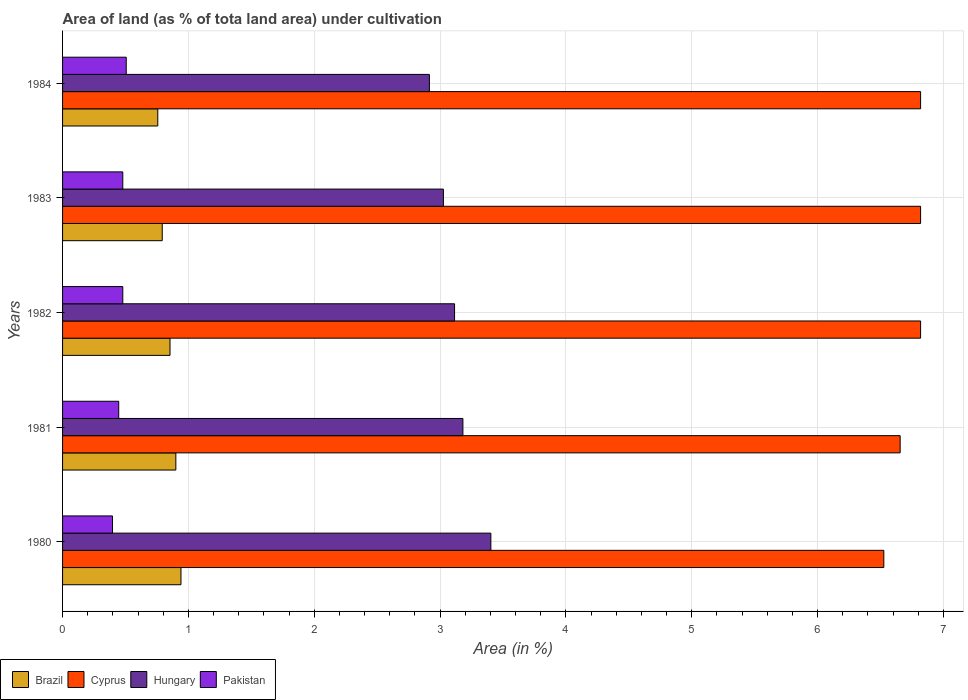How many groups of bars are there?
Give a very brief answer. 5. Are the number of bars per tick equal to the number of legend labels?
Provide a succinct answer. Yes. Are the number of bars on each tick of the Y-axis equal?
Your response must be concise. Yes. How many bars are there on the 2nd tick from the top?
Your answer should be compact. 4. What is the label of the 5th group of bars from the top?
Make the answer very short. 1980. What is the percentage of land under cultivation in Brazil in 1984?
Offer a very short reply. 0.76. Across all years, what is the maximum percentage of land under cultivation in Brazil?
Ensure brevity in your answer.  0.94. Across all years, what is the minimum percentage of land under cultivation in Hungary?
Ensure brevity in your answer.  2.91. In which year was the percentage of land under cultivation in Brazil maximum?
Make the answer very short. 1980. What is the total percentage of land under cultivation in Pakistan in the graph?
Give a very brief answer. 2.31. What is the difference between the percentage of land under cultivation in Hungary in 1980 and that in 1982?
Offer a terse response. 0.29. What is the difference between the percentage of land under cultivation in Brazil in 1983 and the percentage of land under cultivation in Cyprus in 1984?
Your answer should be very brief. -6.03. What is the average percentage of land under cultivation in Hungary per year?
Keep it short and to the point. 3.13. In the year 1984, what is the difference between the percentage of land under cultivation in Hungary and percentage of land under cultivation in Pakistan?
Give a very brief answer. 2.41. In how many years, is the percentage of land under cultivation in Pakistan greater than 1.2 %?
Your answer should be compact. 0. What is the ratio of the percentage of land under cultivation in Pakistan in 1981 to that in 1984?
Provide a short and direct response. 0.88. Is the difference between the percentage of land under cultivation in Hungary in 1982 and 1984 greater than the difference between the percentage of land under cultivation in Pakistan in 1982 and 1984?
Your answer should be very brief. Yes. What is the difference between the highest and the second highest percentage of land under cultivation in Hungary?
Offer a very short reply. 0.22. What is the difference between the highest and the lowest percentage of land under cultivation in Cyprus?
Give a very brief answer. 0.29. In how many years, is the percentage of land under cultivation in Pakistan greater than the average percentage of land under cultivation in Pakistan taken over all years?
Provide a succinct answer. 3. Is the sum of the percentage of land under cultivation in Brazil in 1982 and 1984 greater than the maximum percentage of land under cultivation in Pakistan across all years?
Your answer should be very brief. Yes. What does the 2nd bar from the top in 1980 represents?
Your answer should be very brief. Hungary. What is the difference between two consecutive major ticks on the X-axis?
Keep it short and to the point. 1. Are the values on the major ticks of X-axis written in scientific E-notation?
Ensure brevity in your answer.  No. Does the graph contain grids?
Offer a terse response. Yes. How are the legend labels stacked?
Keep it short and to the point. Horizontal. What is the title of the graph?
Your answer should be very brief. Area of land (as % of tota land area) under cultivation. Does "Morocco" appear as one of the legend labels in the graph?
Your answer should be compact. No. What is the label or title of the X-axis?
Give a very brief answer. Area (in %). What is the Area (in %) in Brazil in 1980?
Offer a terse response. 0.94. What is the Area (in %) of Cyprus in 1980?
Ensure brevity in your answer.  6.53. What is the Area (in %) of Hungary in 1980?
Give a very brief answer. 3.4. What is the Area (in %) of Pakistan in 1980?
Give a very brief answer. 0.4. What is the Area (in %) of Brazil in 1981?
Your answer should be very brief. 0.9. What is the Area (in %) in Cyprus in 1981?
Provide a short and direct response. 6.66. What is the Area (in %) of Hungary in 1981?
Your response must be concise. 3.18. What is the Area (in %) of Pakistan in 1981?
Give a very brief answer. 0.45. What is the Area (in %) of Brazil in 1982?
Provide a short and direct response. 0.85. What is the Area (in %) in Cyprus in 1982?
Your answer should be very brief. 6.82. What is the Area (in %) in Hungary in 1982?
Give a very brief answer. 3.11. What is the Area (in %) in Pakistan in 1982?
Give a very brief answer. 0.48. What is the Area (in %) in Brazil in 1983?
Provide a succinct answer. 0.79. What is the Area (in %) of Cyprus in 1983?
Provide a succinct answer. 6.82. What is the Area (in %) of Hungary in 1983?
Make the answer very short. 3.03. What is the Area (in %) of Pakistan in 1983?
Offer a very short reply. 0.48. What is the Area (in %) in Brazil in 1984?
Your answer should be very brief. 0.76. What is the Area (in %) of Cyprus in 1984?
Provide a succinct answer. 6.82. What is the Area (in %) of Hungary in 1984?
Provide a succinct answer. 2.91. What is the Area (in %) of Pakistan in 1984?
Provide a succinct answer. 0.51. Across all years, what is the maximum Area (in %) in Brazil?
Keep it short and to the point. 0.94. Across all years, what is the maximum Area (in %) in Cyprus?
Provide a short and direct response. 6.82. Across all years, what is the maximum Area (in %) of Hungary?
Offer a very short reply. 3.4. Across all years, what is the maximum Area (in %) in Pakistan?
Make the answer very short. 0.51. Across all years, what is the minimum Area (in %) of Brazil?
Ensure brevity in your answer.  0.76. Across all years, what is the minimum Area (in %) in Cyprus?
Keep it short and to the point. 6.53. Across all years, what is the minimum Area (in %) in Hungary?
Give a very brief answer. 2.91. Across all years, what is the minimum Area (in %) of Pakistan?
Provide a short and direct response. 0.4. What is the total Area (in %) of Brazil in the graph?
Ensure brevity in your answer.  4.24. What is the total Area (in %) of Cyprus in the graph?
Ensure brevity in your answer.  33.64. What is the total Area (in %) of Hungary in the graph?
Offer a very short reply. 15.64. What is the total Area (in %) of Pakistan in the graph?
Your answer should be very brief. 2.31. What is the difference between the Area (in %) in Brazil in 1980 and that in 1981?
Your response must be concise. 0.04. What is the difference between the Area (in %) in Cyprus in 1980 and that in 1981?
Your response must be concise. -0.13. What is the difference between the Area (in %) of Hungary in 1980 and that in 1981?
Provide a short and direct response. 0.22. What is the difference between the Area (in %) of Pakistan in 1980 and that in 1981?
Offer a very short reply. -0.05. What is the difference between the Area (in %) of Brazil in 1980 and that in 1982?
Ensure brevity in your answer.  0.09. What is the difference between the Area (in %) in Cyprus in 1980 and that in 1982?
Ensure brevity in your answer.  -0.29. What is the difference between the Area (in %) in Hungary in 1980 and that in 1982?
Provide a succinct answer. 0.29. What is the difference between the Area (in %) of Pakistan in 1980 and that in 1982?
Offer a very short reply. -0.08. What is the difference between the Area (in %) of Brazil in 1980 and that in 1983?
Give a very brief answer. 0.15. What is the difference between the Area (in %) of Cyprus in 1980 and that in 1983?
Provide a short and direct response. -0.29. What is the difference between the Area (in %) of Hungary in 1980 and that in 1983?
Your answer should be compact. 0.38. What is the difference between the Area (in %) of Pakistan in 1980 and that in 1983?
Ensure brevity in your answer.  -0.08. What is the difference between the Area (in %) of Brazil in 1980 and that in 1984?
Your answer should be very brief. 0.18. What is the difference between the Area (in %) of Cyprus in 1980 and that in 1984?
Provide a short and direct response. -0.29. What is the difference between the Area (in %) in Hungary in 1980 and that in 1984?
Your response must be concise. 0.49. What is the difference between the Area (in %) in Pakistan in 1980 and that in 1984?
Your answer should be very brief. -0.11. What is the difference between the Area (in %) in Brazil in 1981 and that in 1982?
Provide a succinct answer. 0.05. What is the difference between the Area (in %) of Cyprus in 1981 and that in 1982?
Offer a very short reply. -0.16. What is the difference between the Area (in %) in Hungary in 1981 and that in 1982?
Keep it short and to the point. 0.07. What is the difference between the Area (in %) in Pakistan in 1981 and that in 1982?
Make the answer very short. -0.03. What is the difference between the Area (in %) of Brazil in 1981 and that in 1983?
Offer a terse response. 0.11. What is the difference between the Area (in %) in Cyprus in 1981 and that in 1983?
Your response must be concise. -0.16. What is the difference between the Area (in %) of Hungary in 1981 and that in 1983?
Provide a short and direct response. 0.16. What is the difference between the Area (in %) of Pakistan in 1981 and that in 1983?
Provide a short and direct response. -0.03. What is the difference between the Area (in %) of Brazil in 1981 and that in 1984?
Offer a terse response. 0.14. What is the difference between the Area (in %) in Cyprus in 1981 and that in 1984?
Provide a succinct answer. -0.16. What is the difference between the Area (in %) in Hungary in 1981 and that in 1984?
Provide a short and direct response. 0.27. What is the difference between the Area (in %) of Pakistan in 1981 and that in 1984?
Ensure brevity in your answer.  -0.06. What is the difference between the Area (in %) of Brazil in 1982 and that in 1983?
Keep it short and to the point. 0.06. What is the difference between the Area (in %) in Hungary in 1982 and that in 1983?
Ensure brevity in your answer.  0.09. What is the difference between the Area (in %) of Pakistan in 1982 and that in 1983?
Offer a very short reply. 0. What is the difference between the Area (in %) of Brazil in 1982 and that in 1984?
Make the answer very short. 0.1. What is the difference between the Area (in %) in Hungary in 1982 and that in 1984?
Offer a very short reply. 0.2. What is the difference between the Area (in %) in Pakistan in 1982 and that in 1984?
Your answer should be compact. -0.03. What is the difference between the Area (in %) of Brazil in 1983 and that in 1984?
Make the answer very short. 0.04. What is the difference between the Area (in %) of Hungary in 1983 and that in 1984?
Your response must be concise. 0.11. What is the difference between the Area (in %) of Pakistan in 1983 and that in 1984?
Provide a succinct answer. -0.03. What is the difference between the Area (in %) of Brazil in 1980 and the Area (in %) of Cyprus in 1981?
Your response must be concise. -5.71. What is the difference between the Area (in %) of Brazil in 1980 and the Area (in %) of Hungary in 1981?
Your answer should be very brief. -2.24. What is the difference between the Area (in %) of Brazil in 1980 and the Area (in %) of Pakistan in 1981?
Provide a short and direct response. 0.49. What is the difference between the Area (in %) of Cyprus in 1980 and the Area (in %) of Hungary in 1981?
Offer a very short reply. 3.34. What is the difference between the Area (in %) of Cyprus in 1980 and the Area (in %) of Pakistan in 1981?
Provide a short and direct response. 6.08. What is the difference between the Area (in %) of Hungary in 1980 and the Area (in %) of Pakistan in 1981?
Your answer should be compact. 2.96. What is the difference between the Area (in %) in Brazil in 1980 and the Area (in %) in Cyprus in 1982?
Your answer should be compact. -5.88. What is the difference between the Area (in %) of Brazil in 1980 and the Area (in %) of Hungary in 1982?
Provide a short and direct response. -2.17. What is the difference between the Area (in %) in Brazil in 1980 and the Area (in %) in Pakistan in 1982?
Your answer should be very brief. 0.46. What is the difference between the Area (in %) in Cyprus in 1980 and the Area (in %) in Hungary in 1982?
Provide a succinct answer. 3.41. What is the difference between the Area (in %) of Cyprus in 1980 and the Area (in %) of Pakistan in 1982?
Your response must be concise. 6.05. What is the difference between the Area (in %) of Hungary in 1980 and the Area (in %) of Pakistan in 1982?
Give a very brief answer. 2.92. What is the difference between the Area (in %) of Brazil in 1980 and the Area (in %) of Cyprus in 1983?
Provide a succinct answer. -5.88. What is the difference between the Area (in %) of Brazil in 1980 and the Area (in %) of Hungary in 1983?
Your answer should be compact. -2.09. What is the difference between the Area (in %) of Brazil in 1980 and the Area (in %) of Pakistan in 1983?
Provide a succinct answer. 0.46. What is the difference between the Area (in %) of Cyprus in 1980 and the Area (in %) of Hungary in 1983?
Give a very brief answer. 3.5. What is the difference between the Area (in %) in Cyprus in 1980 and the Area (in %) in Pakistan in 1983?
Your answer should be very brief. 6.05. What is the difference between the Area (in %) of Hungary in 1980 and the Area (in %) of Pakistan in 1983?
Your response must be concise. 2.92. What is the difference between the Area (in %) in Brazil in 1980 and the Area (in %) in Cyprus in 1984?
Keep it short and to the point. -5.88. What is the difference between the Area (in %) of Brazil in 1980 and the Area (in %) of Hungary in 1984?
Your answer should be compact. -1.97. What is the difference between the Area (in %) in Brazil in 1980 and the Area (in %) in Pakistan in 1984?
Ensure brevity in your answer.  0.43. What is the difference between the Area (in %) in Cyprus in 1980 and the Area (in %) in Hungary in 1984?
Keep it short and to the point. 3.61. What is the difference between the Area (in %) of Cyprus in 1980 and the Area (in %) of Pakistan in 1984?
Provide a succinct answer. 6.02. What is the difference between the Area (in %) in Hungary in 1980 and the Area (in %) in Pakistan in 1984?
Provide a short and direct response. 2.9. What is the difference between the Area (in %) of Brazil in 1981 and the Area (in %) of Cyprus in 1982?
Make the answer very short. -5.92. What is the difference between the Area (in %) in Brazil in 1981 and the Area (in %) in Hungary in 1982?
Keep it short and to the point. -2.21. What is the difference between the Area (in %) of Brazil in 1981 and the Area (in %) of Pakistan in 1982?
Ensure brevity in your answer.  0.42. What is the difference between the Area (in %) of Cyprus in 1981 and the Area (in %) of Hungary in 1982?
Give a very brief answer. 3.54. What is the difference between the Area (in %) in Cyprus in 1981 and the Area (in %) in Pakistan in 1982?
Give a very brief answer. 6.18. What is the difference between the Area (in %) of Hungary in 1981 and the Area (in %) of Pakistan in 1982?
Keep it short and to the point. 2.7. What is the difference between the Area (in %) of Brazil in 1981 and the Area (in %) of Cyprus in 1983?
Provide a short and direct response. -5.92. What is the difference between the Area (in %) of Brazil in 1981 and the Area (in %) of Hungary in 1983?
Offer a terse response. -2.13. What is the difference between the Area (in %) of Brazil in 1981 and the Area (in %) of Pakistan in 1983?
Make the answer very short. 0.42. What is the difference between the Area (in %) in Cyprus in 1981 and the Area (in %) in Hungary in 1983?
Your answer should be very brief. 3.63. What is the difference between the Area (in %) of Cyprus in 1981 and the Area (in %) of Pakistan in 1983?
Your answer should be very brief. 6.18. What is the difference between the Area (in %) in Hungary in 1981 and the Area (in %) in Pakistan in 1983?
Keep it short and to the point. 2.7. What is the difference between the Area (in %) in Brazil in 1981 and the Area (in %) in Cyprus in 1984?
Your response must be concise. -5.92. What is the difference between the Area (in %) of Brazil in 1981 and the Area (in %) of Hungary in 1984?
Give a very brief answer. -2.01. What is the difference between the Area (in %) of Brazil in 1981 and the Area (in %) of Pakistan in 1984?
Your answer should be very brief. 0.39. What is the difference between the Area (in %) of Cyprus in 1981 and the Area (in %) of Hungary in 1984?
Offer a terse response. 3.74. What is the difference between the Area (in %) of Cyprus in 1981 and the Area (in %) of Pakistan in 1984?
Provide a short and direct response. 6.15. What is the difference between the Area (in %) of Hungary in 1981 and the Area (in %) of Pakistan in 1984?
Give a very brief answer. 2.68. What is the difference between the Area (in %) in Brazil in 1982 and the Area (in %) in Cyprus in 1983?
Keep it short and to the point. -5.96. What is the difference between the Area (in %) of Brazil in 1982 and the Area (in %) of Hungary in 1983?
Give a very brief answer. -2.17. What is the difference between the Area (in %) in Brazil in 1982 and the Area (in %) in Pakistan in 1983?
Offer a very short reply. 0.38. What is the difference between the Area (in %) in Cyprus in 1982 and the Area (in %) in Hungary in 1983?
Your answer should be compact. 3.79. What is the difference between the Area (in %) of Cyprus in 1982 and the Area (in %) of Pakistan in 1983?
Provide a succinct answer. 6.34. What is the difference between the Area (in %) of Hungary in 1982 and the Area (in %) of Pakistan in 1983?
Your answer should be compact. 2.64. What is the difference between the Area (in %) in Brazil in 1982 and the Area (in %) in Cyprus in 1984?
Offer a very short reply. -5.96. What is the difference between the Area (in %) in Brazil in 1982 and the Area (in %) in Hungary in 1984?
Offer a terse response. -2.06. What is the difference between the Area (in %) of Brazil in 1982 and the Area (in %) of Pakistan in 1984?
Your response must be concise. 0.35. What is the difference between the Area (in %) in Cyprus in 1982 and the Area (in %) in Hungary in 1984?
Offer a very short reply. 3.9. What is the difference between the Area (in %) of Cyprus in 1982 and the Area (in %) of Pakistan in 1984?
Provide a succinct answer. 6.31. What is the difference between the Area (in %) of Hungary in 1982 and the Area (in %) of Pakistan in 1984?
Provide a short and direct response. 2.61. What is the difference between the Area (in %) of Brazil in 1983 and the Area (in %) of Cyprus in 1984?
Your response must be concise. -6.03. What is the difference between the Area (in %) of Brazil in 1983 and the Area (in %) of Hungary in 1984?
Give a very brief answer. -2.12. What is the difference between the Area (in %) in Brazil in 1983 and the Area (in %) in Pakistan in 1984?
Your answer should be compact. 0.29. What is the difference between the Area (in %) in Cyprus in 1983 and the Area (in %) in Hungary in 1984?
Provide a succinct answer. 3.9. What is the difference between the Area (in %) in Cyprus in 1983 and the Area (in %) in Pakistan in 1984?
Offer a very short reply. 6.31. What is the difference between the Area (in %) of Hungary in 1983 and the Area (in %) of Pakistan in 1984?
Make the answer very short. 2.52. What is the average Area (in %) in Brazil per year?
Offer a terse response. 0.85. What is the average Area (in %) of Cyprus per year?
Your answer should be compact. 6.73. What is the average Area (in %) in Hungary per year?
Offer a very short reply. 3.13. What is the average Area (in %) of Pakistan per year?
Provide a short and direct response. 0.46. In the year 1980, what is the difference between the Area (in %) in Brazil and Area (in %) in Cyprus?
Keep it short and to the point. -5.59. In the year 1980, what is the difference between the Area (in %) of Brazil and Area (in %) of Hungary?
Your answer should be very brief. -2.46. In the year 1980, what is the difference between the Area (in %) in Brazil and Area (in %) in Pakistan?
Offer a very short reply. 0.54. In the year 1980, what is the difference between the Area (in %) in Cyprus and Area (in %) in Hungary?
Provide a succinct answer. 3.12. In the year 1980, what is the difference between the Area (in %) of Cyprus and Area (in %) of Pakistan?
Your response must be concise. 6.13. In the year 1980, what is the difference between the Area (in %) in Hungary and Area (in %) in Pakistan?
Make the answer very short. 3.01. In the year 1981, what is the difference between the Area (in %) in Brazil and Area (in %) in Cyprus?
Provide a short and direct response. -5.76. In the year 1981, what is the difference between the Area (in %) in Brazil and Area (in %) in Hungary?
Make the answer very short. -2.28. In the year 1981, what is the difference between the Area (in %) of Brazil and Area (in %) of Pakistan?
Make the answer very short. 0.45. In the year 1981, what is the difference between the Area (in %) of Cyprus and Area (in %) of Hungary?
Provide a short and direct response. 3.47. In the year 1981, what is the difference between the Area (in %) of Cyprus and Area (in %) of Pakistan?
Your answer should be compact. 6.21. In the year 1981, what is the difference between the Area (in %) of Hungary and Area (in %) of Pakistan?
Keep it short and to the point. 2.74. In the year 1982, what is the difference between the Area (in %) in Brazil and Area (in %) in Cyprus?
Provide a succinct answer. -5.96. In the year 1982, what is the difference between the Area (in %) in Brazil and Area (in %) in Hungary?
Provide a succinct answer. -2.26. In the year 1982, what is the difference between the Area (in %) of Brazil and Area (in %) of Pakistan?
Make the answer very short. 0.38. In the year 1982, what is the difference between the Area (in %) in Cyprus and Area (in %) in Hungary?
Your answer should be compact. 3.7. In the year 1982, what is the difference between the Area (in %) of Cyprus and Area (in %) of Pakistan?
Keep it short and to the point. 6.34. In the year 1982, what is the difference between the Area (in %) of Hungary and Area (in %) of Pakistan?
Ensure brevity in your answer.  2.64. In the year 1983, what is the difference between the Area (in %) of Brazil and Area (in %) of Cyprus?
Ensure brevity in your answer.  -6.03. In the year 1983, what is the difference between the Area (in %) in Brazil and Area (in %) in Hungary?
Offer a very short reply. -2.23. In the year 1983, what is the difference between the Area (in %) in Brazil and Area (in %) in Pakistan?
Offer a terse response. 0.31. In the year 1983, what is the difference between the Area (in %) of Cyprus and Area (in %) of Hungary?
Give a very brief answer. 3.79. In the year 1983, what is the difference between the Area (in %) of Cyprus and Area (in %) of Pakistan?
Provide a short and direct response. 6.34. In the year 1983, what is the difference between the Area (in %) in Hungary and Area (in %) in Pakistan?
Keep it short and to the point. 2.55. In the year 1984, what is the difference between the Area (in %) in Brazil and Area (in %) in Cyprus?
Provide a succinct answer. -6.06. In the year 1984, what is the difference between the Area (in %) in Brazil and Area (in %) in Hungary?
Provide a short and direct response. -2.16. In the year 1984, what is the difference between the Area (in %) in Brazil and Area (in %) in Pakistan?
Your answer should be very brief. 0.25. In the year 1984, what is the difference between the Area (in %) of Cyprus and Area (in %) of Hungary?
Offer a very short reply. 3.9. In the year 1984, what is the difference between the Area (in %) in Cyprus and Area (in %) in Pakistan?
Offer a very short reply. 6.31. In the year 1984, what is the difference between the Area (in %) in Hungary and Area (in %) in Pakistan?
Your answer should be compact. 2.41. What is the ratio of the Area (in %) of Brazil in 1980 to that in 1981?
Give a very brief answer. 1.05. What is the ratio of the Area (in %) in Cyprus in 1980 to that in 1981?
Your answer should be compact. 0.98. What is the ratio of the Area (in %) of Hungary in 1980 to that in 1981?
Keep it short and to the point. 1.07. What is the ratio of the Area (in %) of Pakistan in 1980 to that in 1981?
Make the answer very short. 0.89. What is the ratio of the Area (in %) of Brazil in 1980 to that in 1982?
Make the answer very short. 1.1. What is the ratio of the Area (in %) in Cyprus in 1980 to that in 1982?
Your answer should be very brief. 0.96. What is the ratio of the Area (in %) in Hungary in 1980 to that in 1982?
Provide a short and direct response. 1.09. What is the ratio of the Area (in %) of Pakistan in 1980 to that in 1982?
Keep it short and to the point. 0.83. What is the ratio of the Area (in %) of Brazil in 1980 to that in 1983?
Give a very brief answer. 1.19. What is the ratio of the Area (in %) of Cyprus in 1980 to that in 1983?
Offer a very short reply. 0.96. What is the ratio of the Area (in %) of Hungary in 1980 to that in 1983?
Offer a terse response. 1.12. What is the ratio of the Area (in %) of Pakistan in 1980 to that in 1983?
Offer a very short reply. 0.83. What is the ratio of the Area (in %) in Brazil in 1980 to that in 1984?
Your answer should be very brief. 1.24. What is the ratio of the Area (in %) in Cyprus in 1980 to that in 1984?
Ensure brevity in your answer.  0.96. What is the ratio of the Area (in %) of Hungary in 1980 to that in 1984?
Offer a very short reply. 1.17. What is the ratio of the Area (in %) in Pakistan in 1980 to that in 1984?
Your answer should be compact. 0.78. What is the ratio of the Area (in %) in Brazil in 1981 to that in 1982?
Your answer should be very brief. 1.05. What is the ratio of the Area (in %) in Cyprus in 1981 to that in 1982?
Provide a short and direct response. 0.98. What is the ratio of the Area (in %) of Hungary in 1981 to that in 1982?
Your response must be concise. 1.02. What is the ratio of the Area (in %) in Pakistan in 1981 to that in 1982?
Provide a short and direct response. 0.93. What is the ratio of the Area (in %) of Brazil in 1981 to that in 1983?
Provide a short and direct response. 1.14. What is the ratio of the Area (in %) in Cyprus in 1981 to that in 1983?
Provide a short and direct response. 0.98. What is the ratio of the Area (in %) in Hungary in 1981 to that in 1983?
Make the answer very short. 1.05. What is the ratio of the Area (in %) of Pakistan in 1981 to that in 1983?
Offer a terse response. 0.93. What is the ratio of the Area (in %) in Brazil in 1981 to that in 1984?
Your answer should be compact. 1.19. What is the ratio of the Area (in %) in Cyprus in 1981 to that in 1984?
Offer a terse response. 0.98. What is the ratio of the Area (in %) in Hungary in 1981 to that in 1984?
Give a very brief answer. 1.09. What is the ratio of the Area (in %) of Pakistan in 1981 to that in 1984?
Your answer should be compact. 0.88. What is the ratio of the Area (in %) of Brazil in 1982 to that in 1983?
Your answer should be very brief. 1.08. What is the ratio of the Area (in %) of Cyprus in 1982 to that in 1983?
Your answer should be compact. 1. What is the ratio of the Area (in %) of Hungary in 1982 to that in 1983?
Make the answer very short. 1.03. What is the ratio of the Area (in %) of Brazil in 1982 to that in 1984?
Provide a succinct answer. 1.13. What is the ratio of the Area (in %) in Hungary in 1982 to that in 1984?
Ensure brevity in your answer.  1.07. What is the ratio of the Area (in %) of Pakistan in 1982 to that in 1984?
Provide a short and direct response. 0.95. What is the ratio of the Area (in %) in Brazil in 1983 to that in 1984?
Your answer should be compact. 1.05. What is the ratio of the Area (in %) in Hungary in 1983 to that in 1984?
Make the answer very short. 1.04. What is the ratio of the Area (in %) of Pakistan in 1983 to that in 1984?
Offer a very short reply. 0.95. What is the difference between the highest and the second highest Area (in %) in Brazil?
Make the answer very short. 0.04. What is the difference between the highest and the second highest Area (in %) of Hungary?
Your answer should be very brief. 0.22. What is the difference between the highest and the second highest Area (in %) of Pakistan?
Ensure brevity in your answer.  0.03. What is the difference between the highest and the lowest Area (in %) of Brazil?
Offer a terse response. 0.18. What is the difference between the highest and the lowest Area (in %) in Cyprus?
Your answer should be compact. 0.29. What is the difference between the highest and the lowest Area (in %) of Hungary?
Make the answer very short. 0.49. What is the difference between the highest and the lowest Area (in %) in Pakistan?
Your response must be concise. 0.11. 